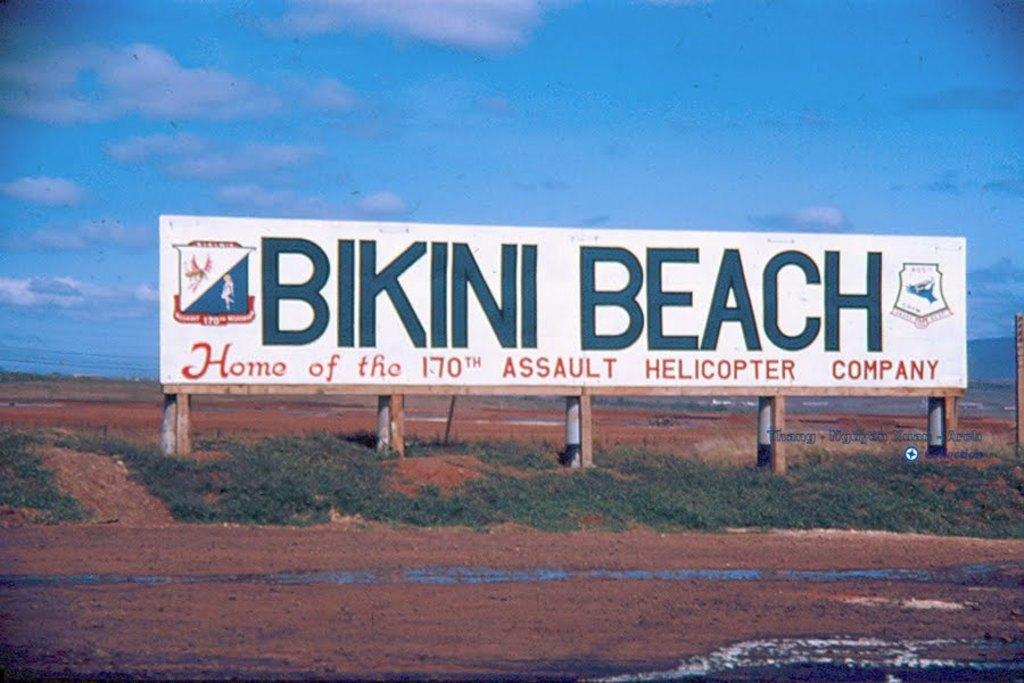<image>
Render a clear and concise summary of the photo. The 170th Assault Helicopter Company is headquartered at Bikini Beach. 